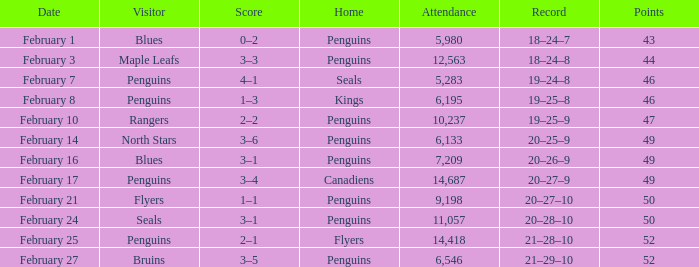Score of 2–1 has what record? 21–28–10. 